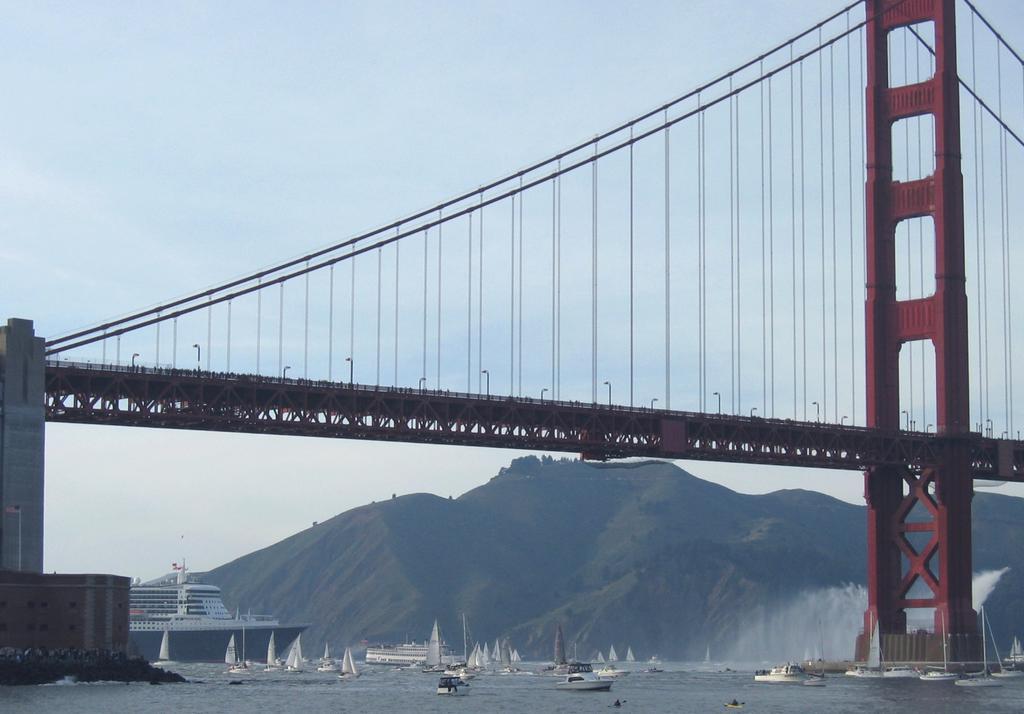Could you give a brief overview of what you see in this image? In the picture we can see a bridge and to it we can see a huge stand which is red in color and on the bridge we can see some poles and under the bridge we can see water and some boats, ship on it and behind it we can see a hill and in the background we can see a sky. 